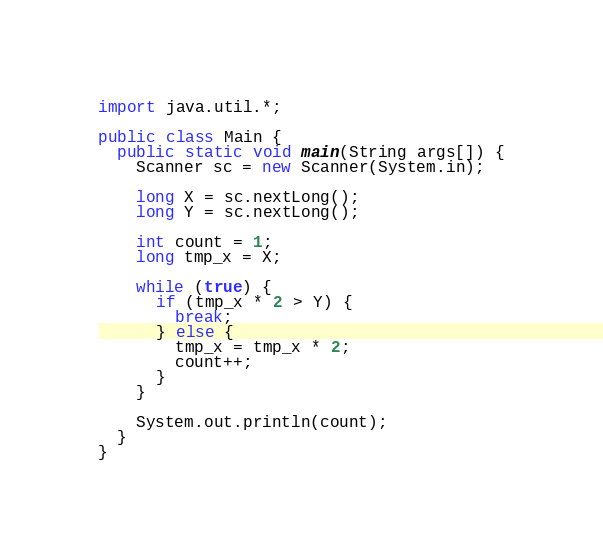<code> <loc_0><loc_0><loc_500><loc_500><_Java_>import java.util.*;

public class Main {
  public static void main(String args[]) {
    Scanner sc = new Scanner(System.in);

    long X = sc.nextLong();
    long Y = sc.nextLong();

    int count = 1;
    long tmp_x = X;

    while (true) {
      if (tmp_x * 2 > Y) {
        break;
      } else {
        tmp_x = tmp_x * 2;
        count++;
      }
    }

    System.out.println(count);
  }
}
</code> 